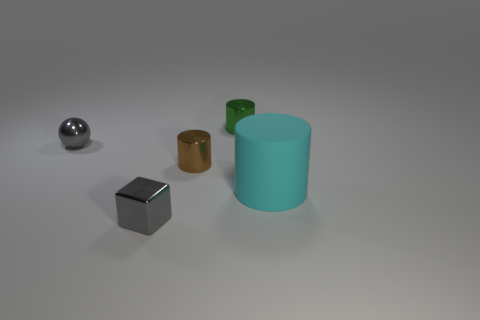Can you describe the lighting in the scene where these objects are placed? The lighting in the scene is soft and diffused, suggesting an indoor setting with possibly overhead ambient lighting, which creates gentle shadows below the objects, enhancing their three-dimensional appearance. 